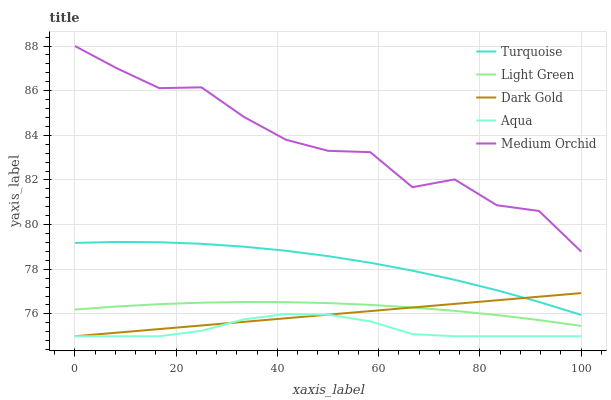Does Aqua have the minimum area under the curve?
Answer yes or no. Yes. Does Medium Orchid have the maximum area under the curve?
Answer yes or no. Yes. Does Medium Orchid have the minimum area under the curve?
Answer yes or no. No. Does Aqua have the maximum area under the curve?
Answer yes or no. No. Is Dark Gold the smoothest?
Answer yes or no. Yes. Is Medium Orchid the roughest?
Answer yes or no. Yes. Is Aqua the smoothest?
Answer yes or no. No. Is Aqua the roughest?
Answer yes or no. No. Does Aqua have the lowest value?
Answer yes or no. Yes. Does Medium Orchid have the lowest value?
Answer yes or no. No. Does Medium Orchid have the highest value?
Answer yes or no. Yes. Does Aqua have the highest value?
Answer yes or no. No. Is Aqua less than Medium Orchid?
Answer yes or no. Yes. Is Turquoise greater than Aqua?
Answer yes or no. Yes. Does Turquoise intersect Dark Gold?
Answer yes or no. Yes. Is Turquoise less than Dark Gold?
Answer yes or no. No. Is Turquoise greater than Dark Gold?
Answer yes or no. No. Does Aqua intersect Medium Orchid?
Answer yes or no. No. 